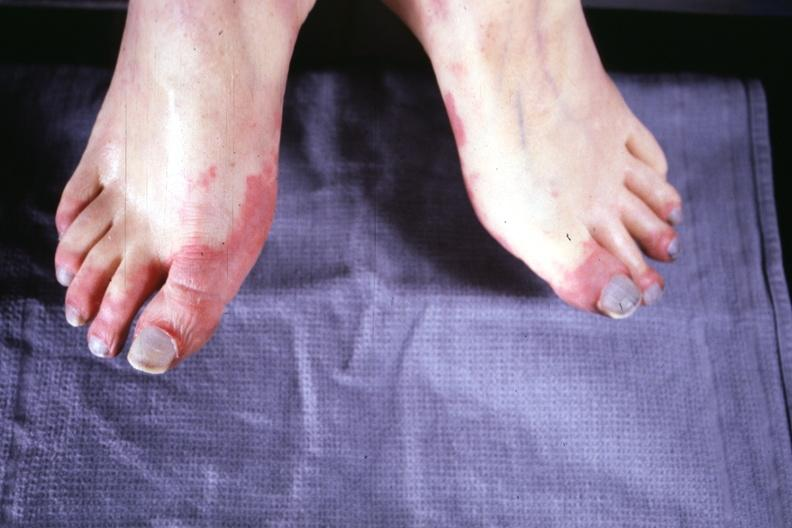s feet present?
Answer the question using a single word or phrase. Yes 